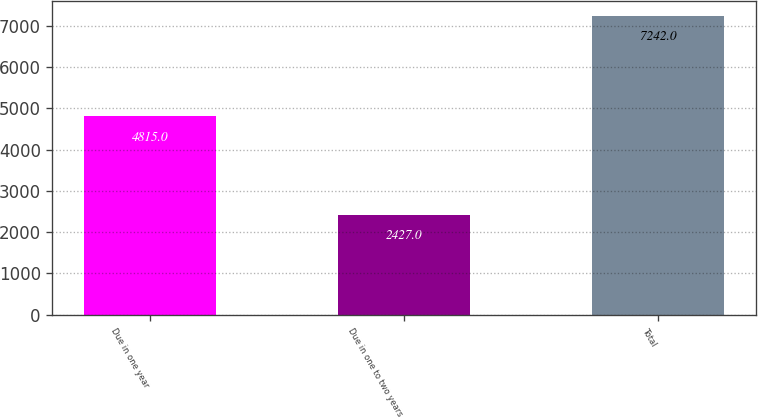Convert chart to OTSL. <chart><loc_0><loc_0><loc_500><loc_500><bar_chart><fcel>Due in one year<fcel>Due in one to two years<fcel>Total<nl><fcel>4815<fcel>2427<fcel>7242<nl></chart> 